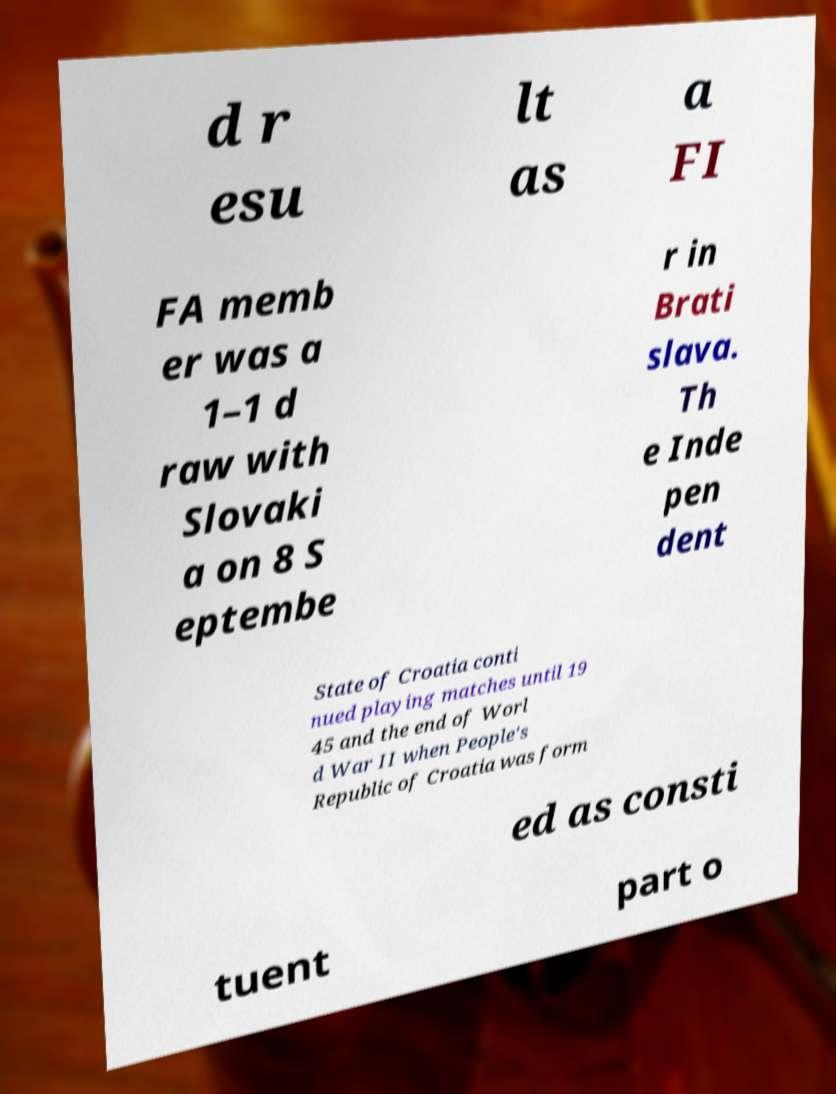Please read and relay the text visible in this image. What does it say? d r esu lt as a FI FA memb er was a 1–1 d raw with Slovaki a on 8 S eptembe r in Brati slava. Th e Inde pen dent State of Croatia conti nued playing matches until 19 45 and the end of Worl d War II when People's Republic of Croatia was form ed as consti tuent part o 